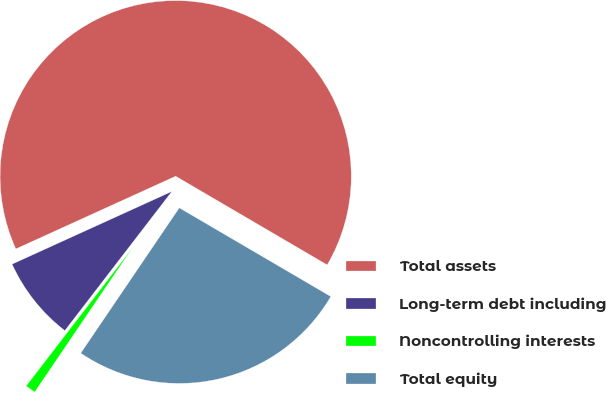Convert chart. <chart><loc_0><loc_0><loc_500><loc_500><pie_chart><fcel>Total assets<fcel>Long-term debt including<fcel>Noncontrolling interests<fcel>Total equity<nl><fcel>65.23%<fcel>7.77%<fcel>0.95%<fcel>26.06%<nl></chart> 